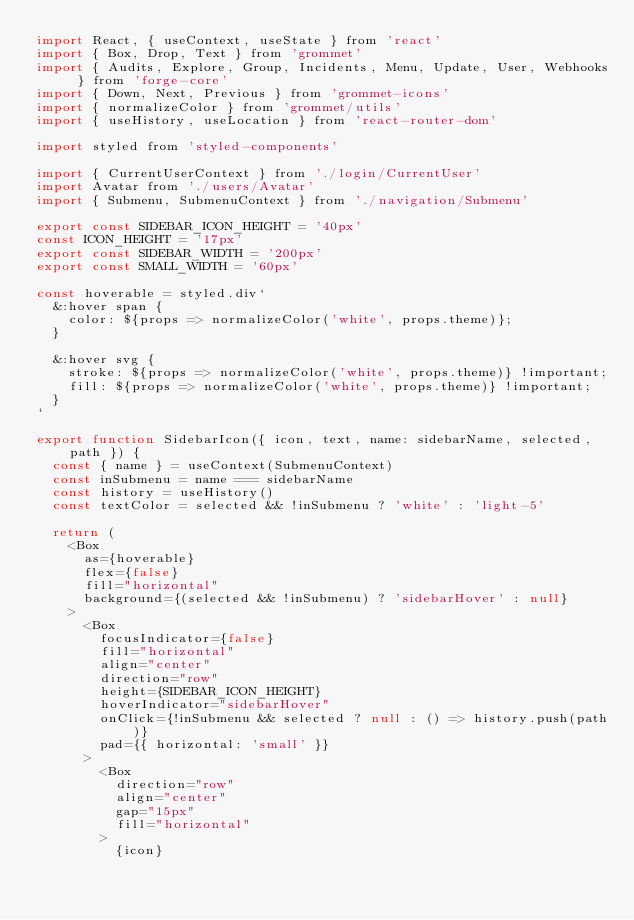Convert code to text. <code><loc_0><loc_0><loc_500><loc_500><_JavaScript_>import React, { useContext, useState } from 'react'
import { Box, Drop, Text } from 'grommet'
import { Audits, Explore, Group, Incidents, Menu, Update, User, Webhooks } from 'forge-core'
import { Down, Next, Previous } from 'grommet-icons'
import { normalizeColor } from 'grommet/utils'
import { useHistory, useLocation } from 'react-router-dom'

import styled from 'styled-components'

import { CurrentUserContext } from './login/CurrentUser'
import Avatar from './users/Avatar'
import { Submenu, SubmenuContext } from './navigation/Submenu'

export const SIDEBAR_ICON_HEIGHT = '40px'
const ICON_HEIGHT = '17px'
export const SIDEBAR_WIDTH = '200px'
export const SMALL_WIDTH = '60px'

const hoverable = styled.div`
  &:hover span {
    color: ${props => normalizeColor('white', props.theme)};
  }

  &:hover svg {
    stroke: ${props => normalizeColor('white', props.theme)} !important;
    fill: ${props => normalizeColor('white', props.theme)} !important;
  }
`

export function SidebarIcon({ icon, text, name: sidebarName, selected, path }) {
  const { name } = useContext(SubmenuContext)
  const inSubmenu = name === sidebarName
  const history = useHistory()
  const textColor = selected && !inSubmenu ? 'white' : 'light-5'

  return (
    <Box
      as={hoverable}
      flex={false}
      fill="horizontal"
      background={(selected && !inSubmenu) ? 'sidebarHover' : null}
    >
      <Box
        focusIndicator={false}
        fill="horizontal"
        align="center"
        direction="row" 
        height={SIDEBAR_ICON_HEIGHT}
        hoverIndicator="sidebarHover" 
        onClick={!inSubmenu && selected ? null : () => history.push(path)} 
        pad={{ horizontal: 'small' }}
      >
        <Box
          direction="row"
          align="center"
          gap="15px"
          fill="horizontal"
        >
          {icon}</code> 